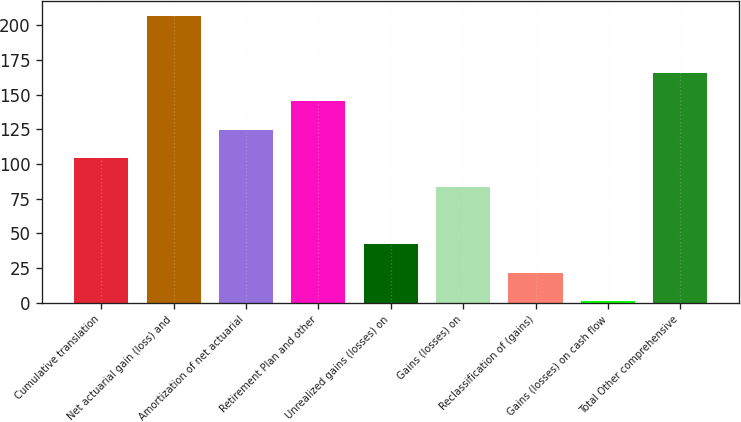Convert chart. <chart><loc_0><loc_0><loc_500><loc_500><bar_chart><fcel>Cumulative translation<fcel>Net actuarial gain (loss) and<fcel>Amortization of net actuarial<fcel>Retirement Plan and other<fcel>Unrealized gains (losses) on<fcel>Gains (losses) on<fcel>Reclassification of (gains)<fcel>Gains (losses) on cash flow<fcel>Total Other comprehensive<nl><fcel>104<fcel>207<fcel>124.6<fcel>145.2<fcel>42.2<fcel>83.4<fcel>21.6<fcel>1<fcel>165.8<nl></chart> 